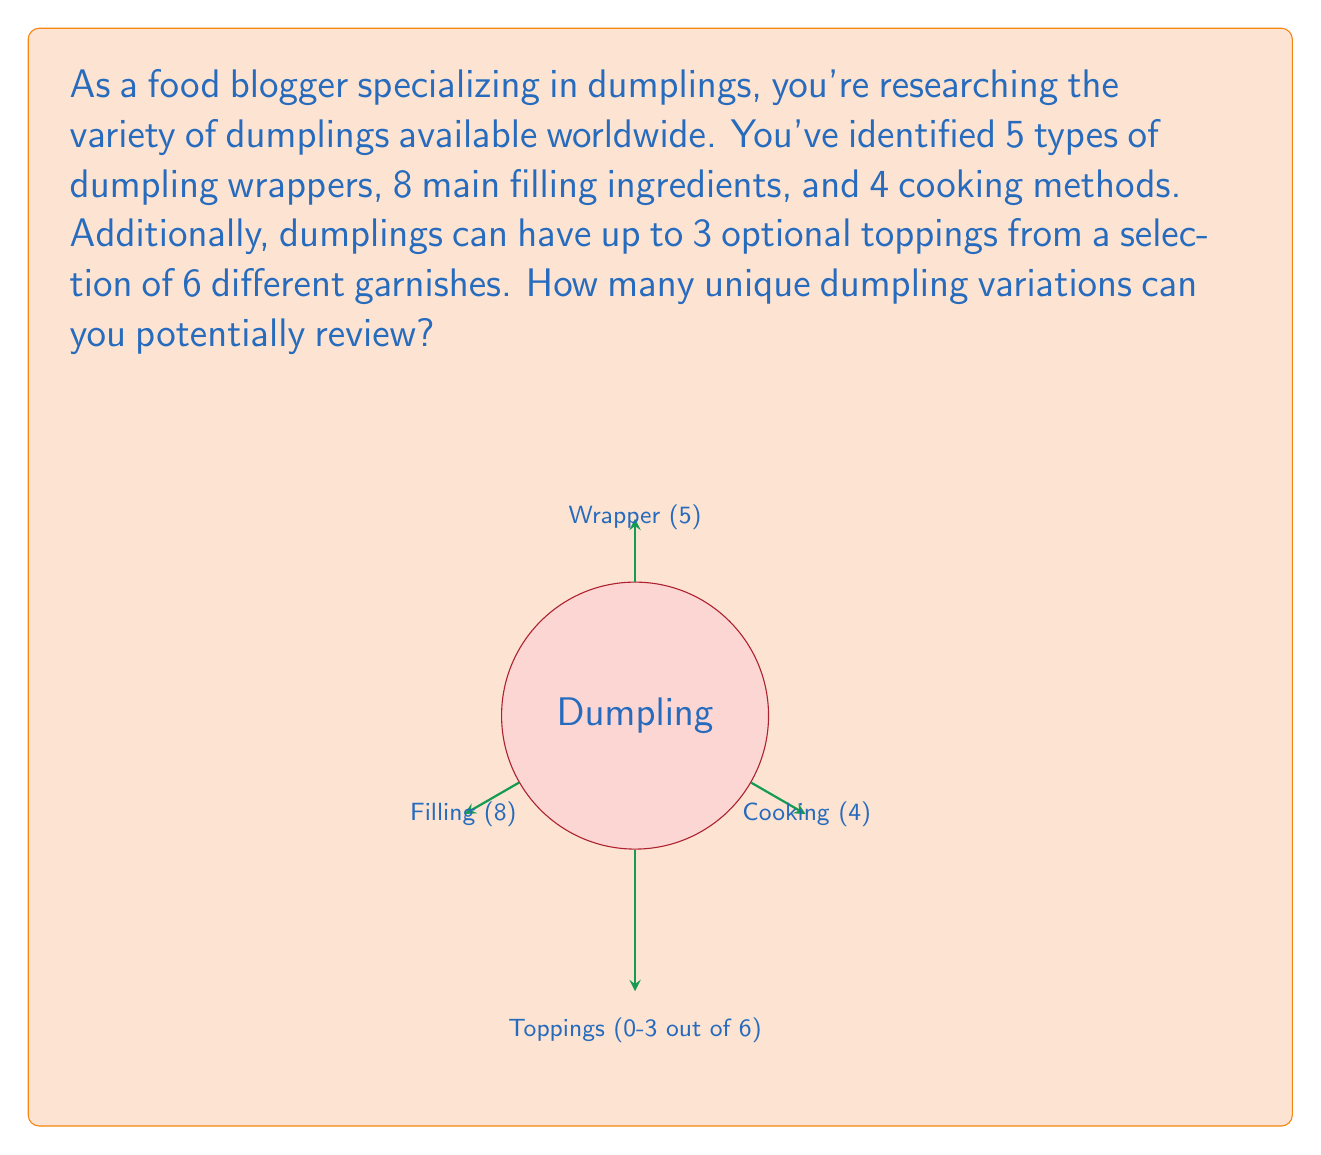Can you answer this question? Let's break this down step-by-step using the fundamental counting principle and combination theory:

1) First, let's consider the core dumpling:
   - 5 types of wrappers
   - 8 main filling ingredients
   - 4 cooking methods
   
   The number of core dumpling variations is:
   $$5 \times 8 \times 4 = 160$$

2) Now, let's consider the toppings. We can have 0, 1, 2, or 3 toppings from 6 options.
   This is equivalent to choosing 0, 1, 2, or 3 items from a set of 6, which can be calculated using combinations:

   - 0 toppings: $\binom{6}{0} = 1$
   - 1 topping:  $\binom{6}{1} = 6$
   - 2 toppings: $\binom{6}{2} = 15$
   - 3 toppings: $\binom{6}{3} = 20$

   Total topping combinations: $1 + 6 + 15 + 20 = 42$

3) By the fundamental counting principle, we multiply the number of core dumpling variations by the number of topping combinations:

   $$160 \times 42 = 6,720$$

Therefore, there are 6,720 unique dumpling variations to potentially review.
Answer: 6,720 variations 